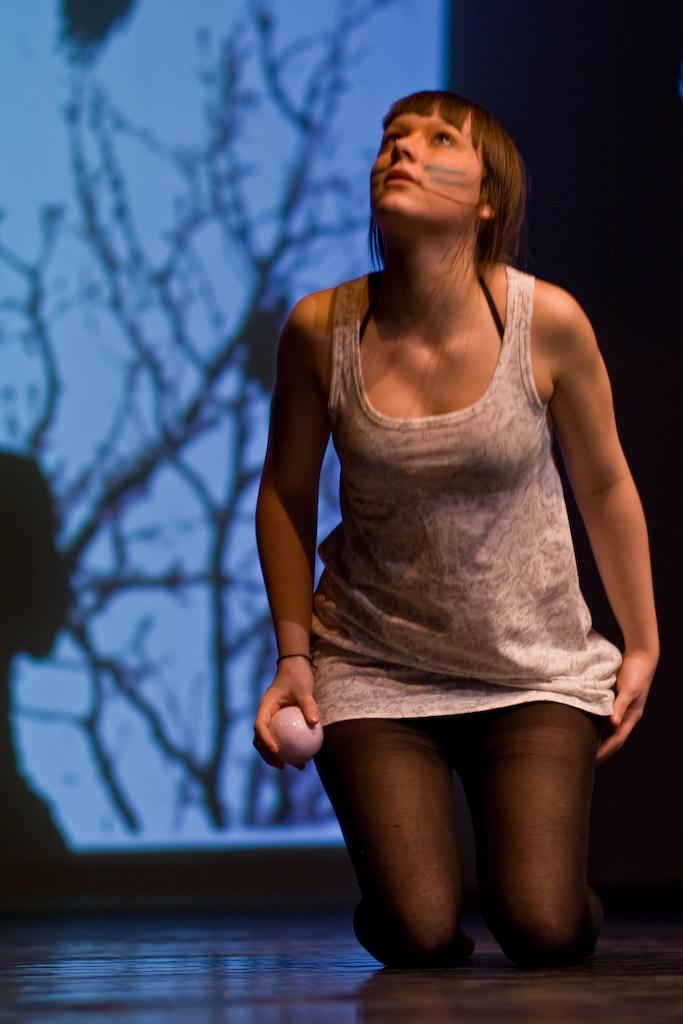Who is present in the image? There is a woman in the image. What is the woman holding in the image? The woman is holding a ball. What surface is visible in the image? There is a floor visible in the image. What type of food is the woman eating in the image? There is no food present in the image; the woman is holding a ball. 